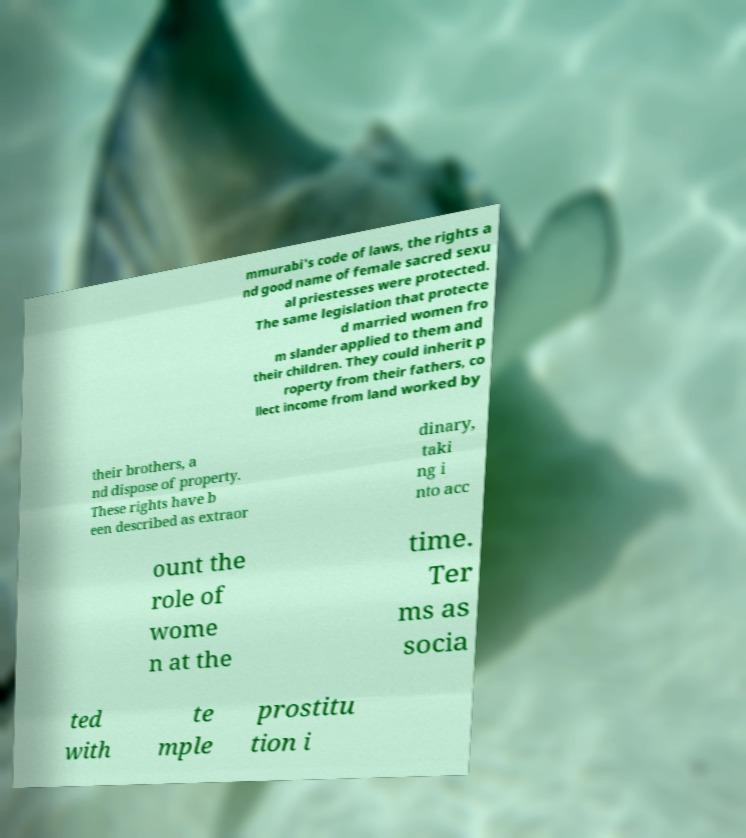Can you accurately transcribe the text from the provided image for me? mmurabi's code of laws, the rights a nd good name of female sacred sexu al priestesses were protected. The same legislation that protecte d married women fro m slander applied to them and their children. They could inherit p roperty from their fathers, co llect income from land worked by their brothers, a nd dispose of property. These rights have b een described as extraor dinary, taki ng i nto acc ount the role of wome n at the time. Ter ms as socia ted with te mple prostitu tion i 